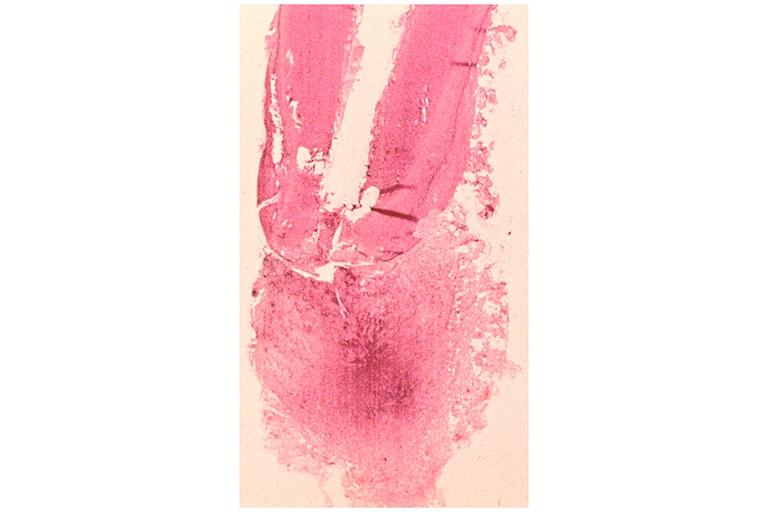s oral present?
Answer the question using a single word or phrase. Yes 